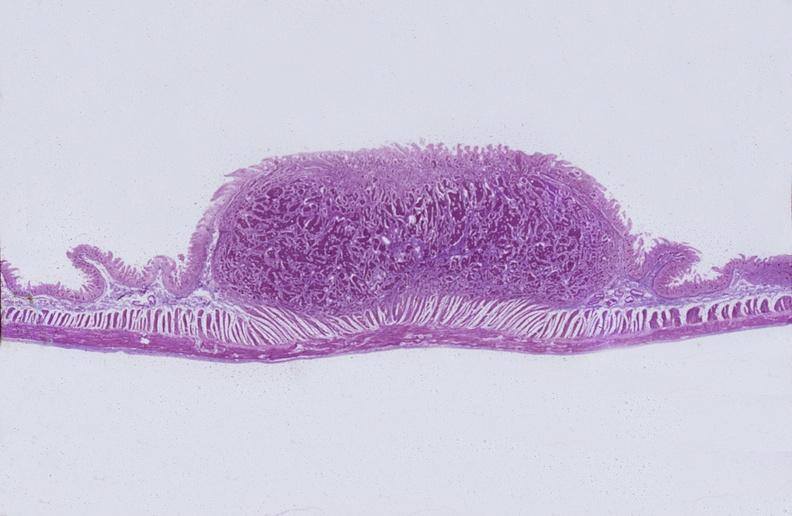what does this image show?
Answer the question using a single word or phrase. Intestine 